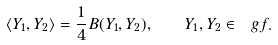Convert formula to latex. <formula><loc_0><loc_0><loc_500><loc_500>\langle Y _ { 1 } , Y _ { 2 } \rangle = \frac { 1 } { 4 } B ( Y _ { 1 } , Y _ { 2 } ) , \quad Y _ { 1 } , Y _ { 2 } \in \ g f .</formula> 